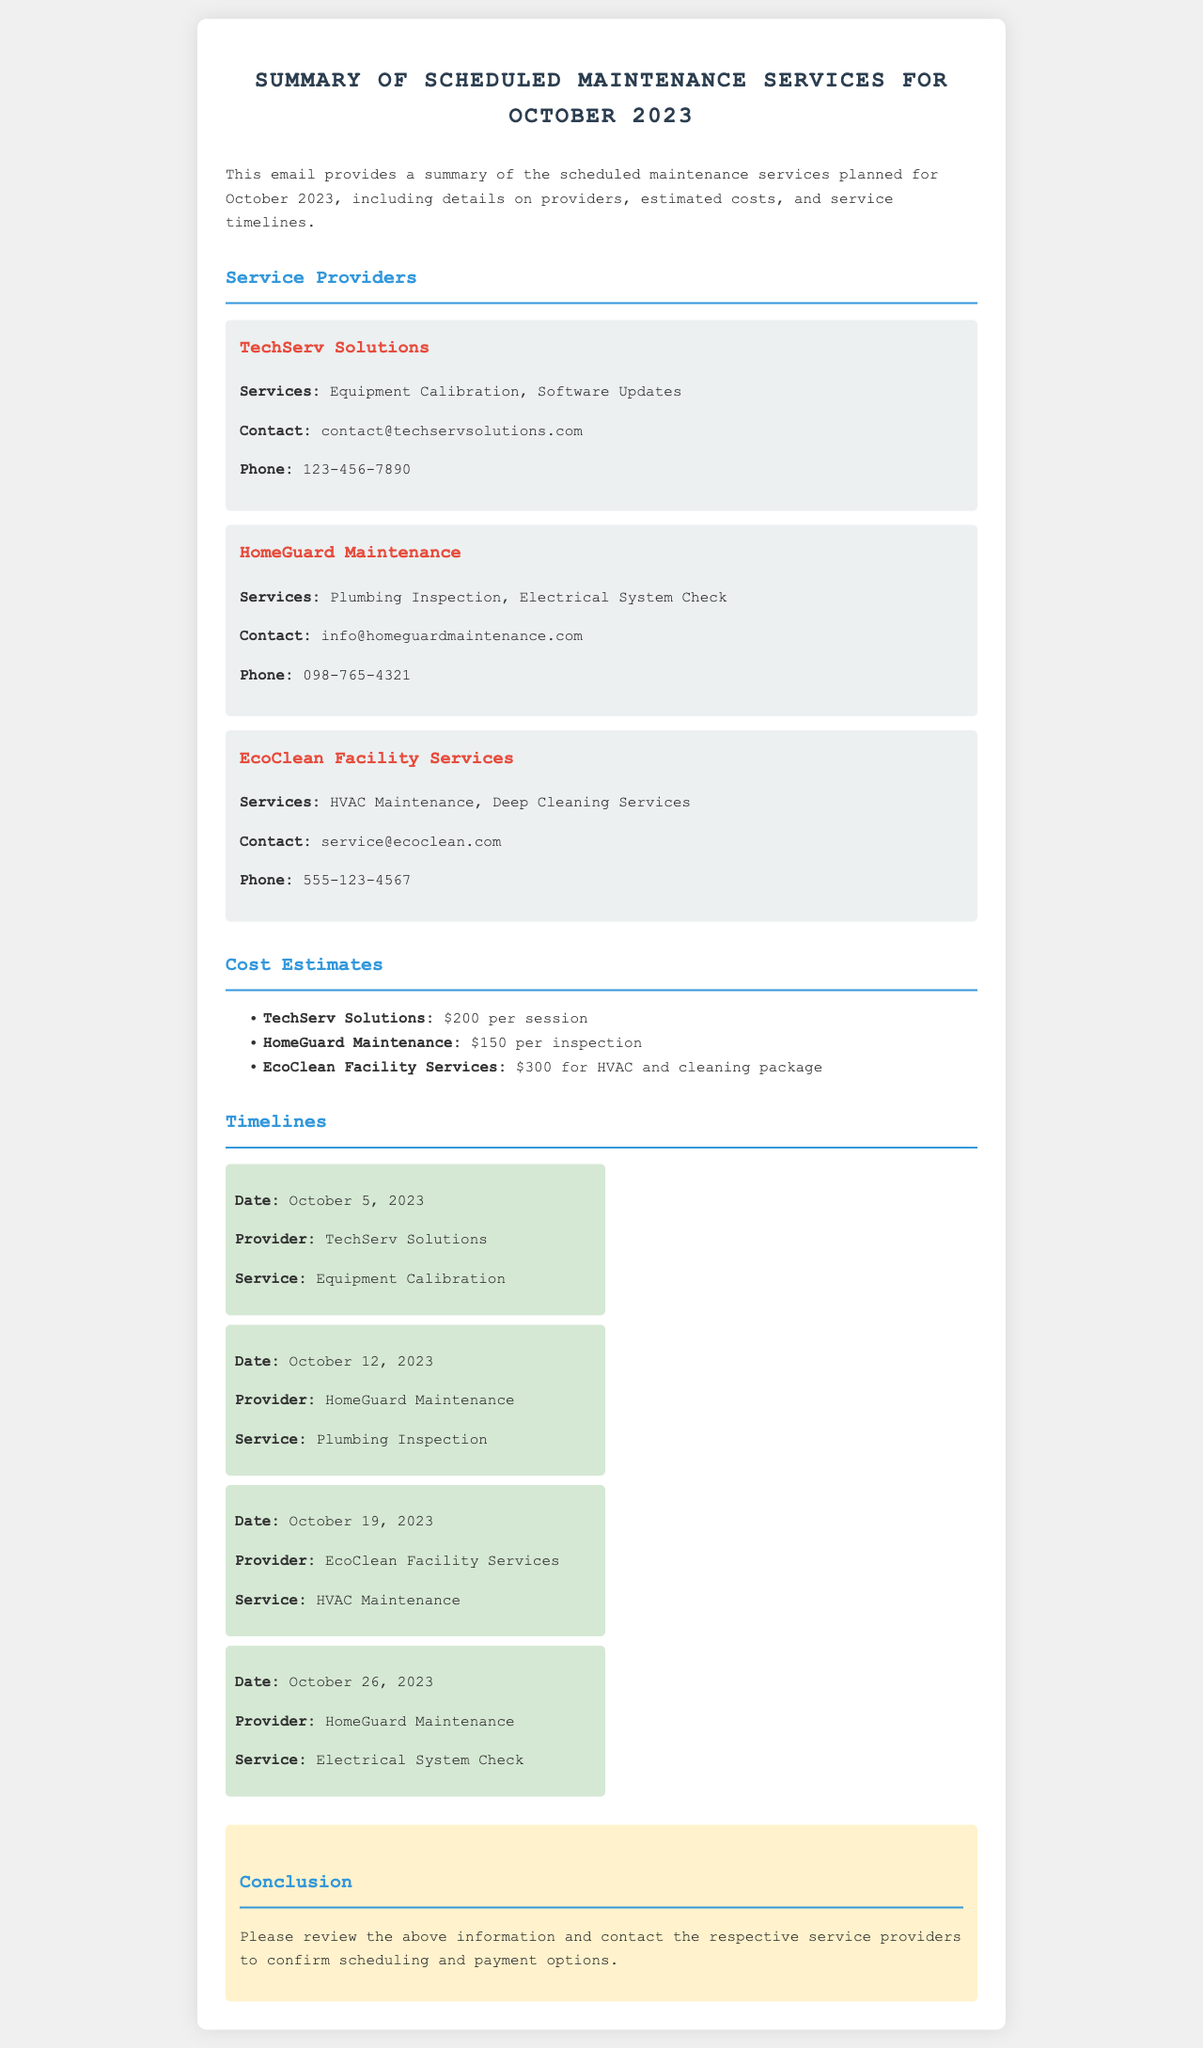what is the date of the Equipment Calibration service? The Equipment Calibration service is scheduled for October 5, 2023.
Answer: October 5, 2023 how much does HomeGuard Maintenance charge for a Plumbing Inspection? HomeGuard Maintenance charges $150 per inspection.
Answer: $150 which provider offers HVAC Maintenance? EcoClean Facility Services offers HVAC Maintenance.
Answer: EcoClean Facility Services what service is scheduled for October 26, 2023? The service on October 26, 2023, is an Electrical System Check by HomeGuard Maintenance.
Answer: Electrical System Check how many service providers are listed in the document? There are three service providers listed in the document.
Answer: three what is the total cost of the HVAC and cleaning package by EcoClean Facility Services? The total cost of the HVAC and cleaning package by EcoClean Facility Services is $300.
Answer: $300 who should be contacted for service confirmation? The respective service providers should be contacted for confirmation.
Answer: respective service providers what type of services does TechServ Solutions provide? TechServ Solutions provides Equipment Calibration and Software Updates.
Answer: Equipment Calibration, Software Updates 